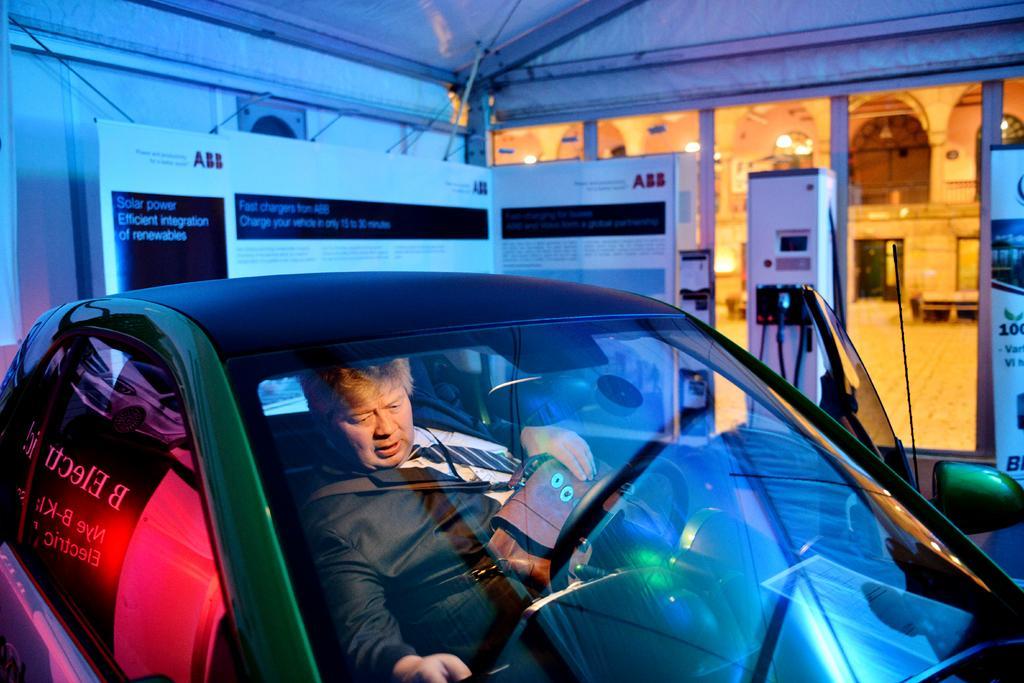Could you give a brief overview of what you see in this image? In this image I see a car in which there is a person who is sitting and In the background I see the board and a building. 